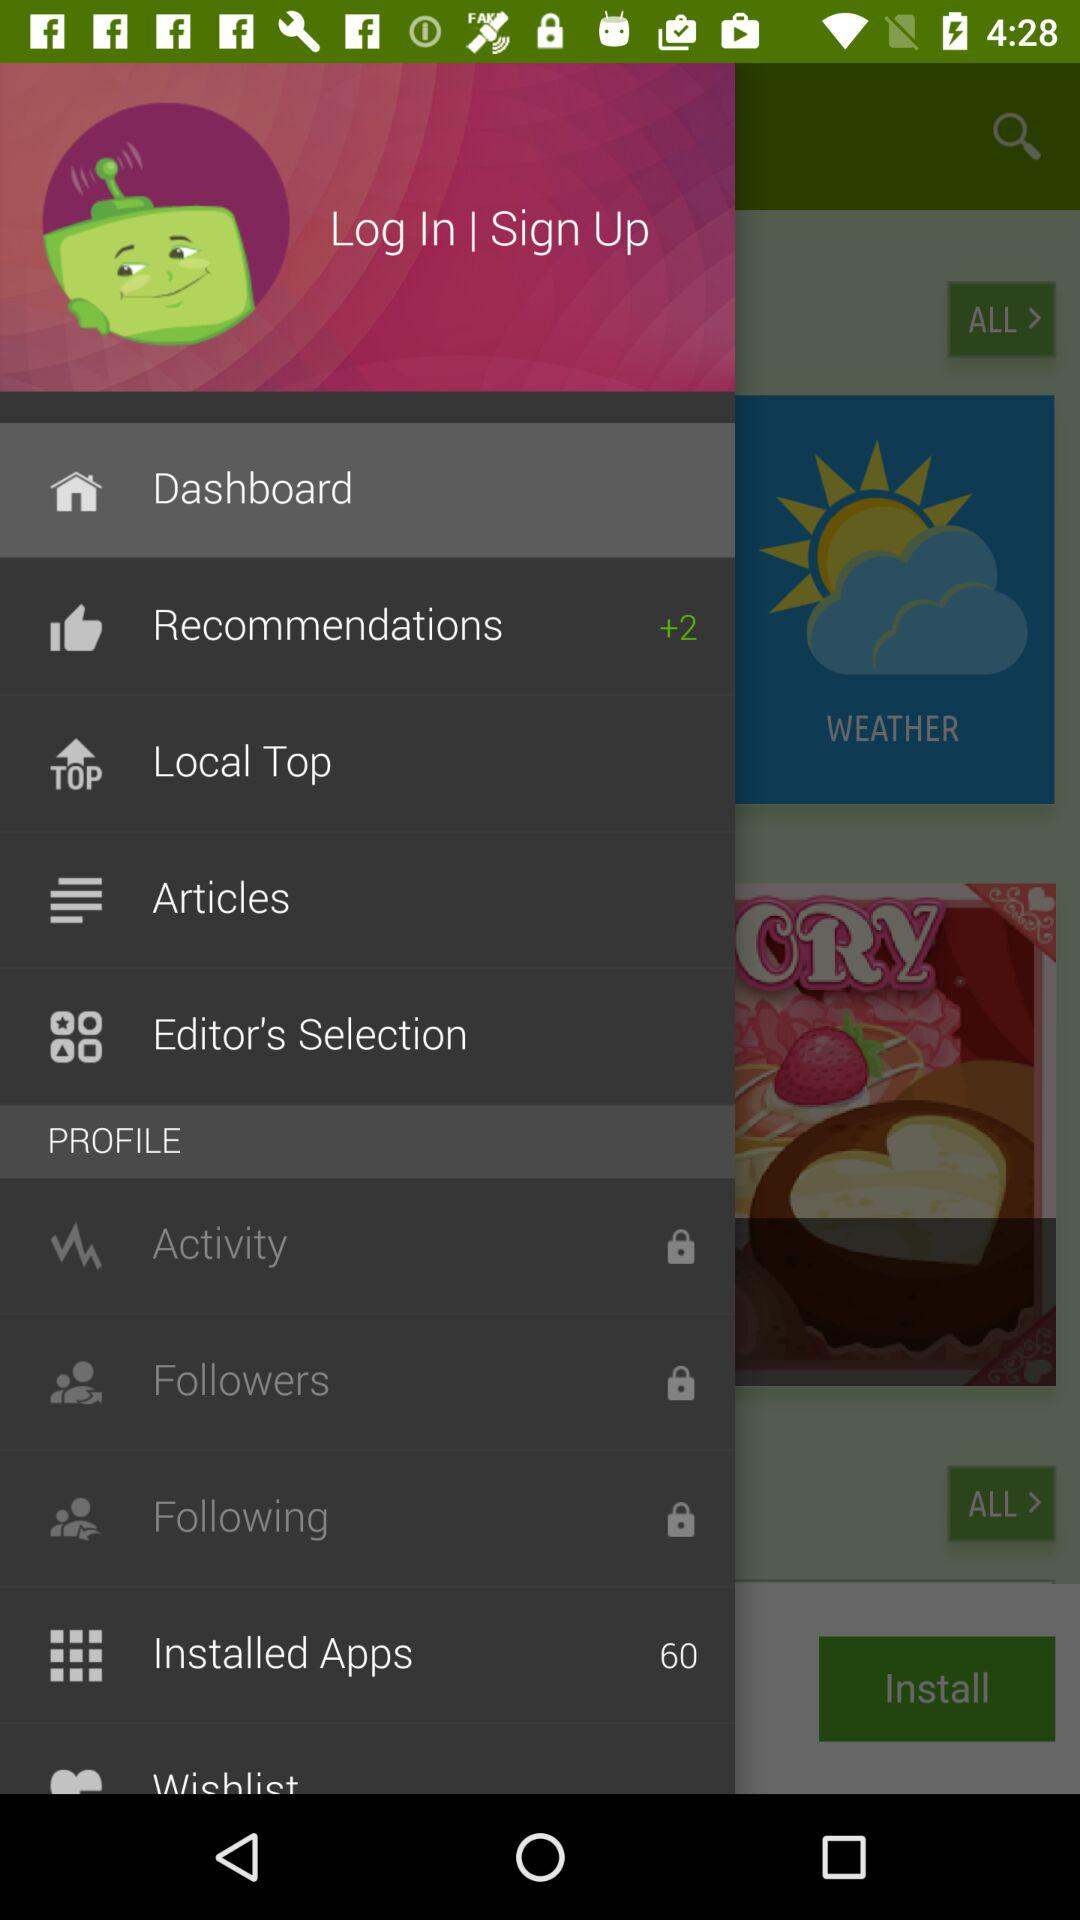Which item is selected? The item "Dashboard" is selected. 